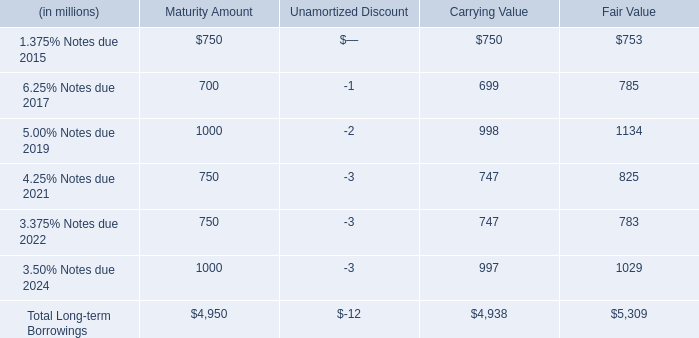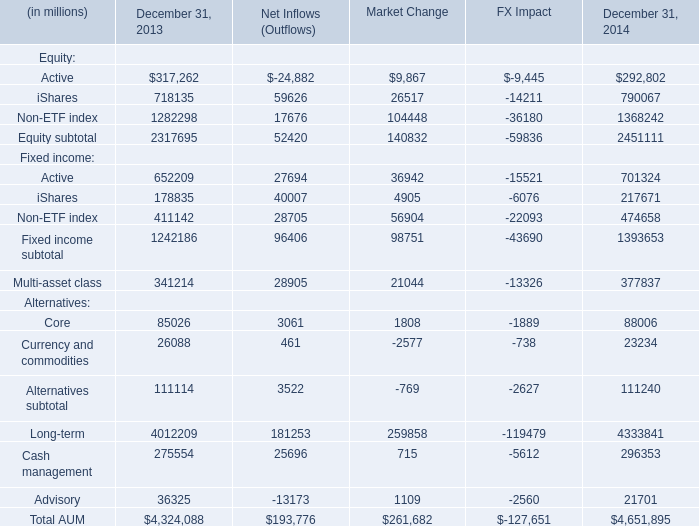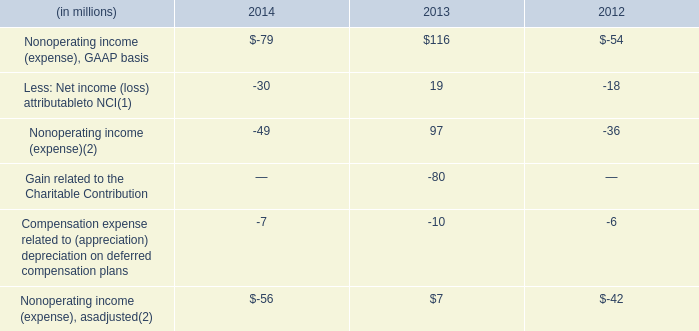what is the fair value of all notes due by 2019 ? in millions $ . 
Computations: (1134 + (753 + 785))
Answer: 2672.0. 